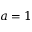Convert formula to latex. <formula><loc_0><loc_0><loc_500><loc_500>a = 1</formula> 